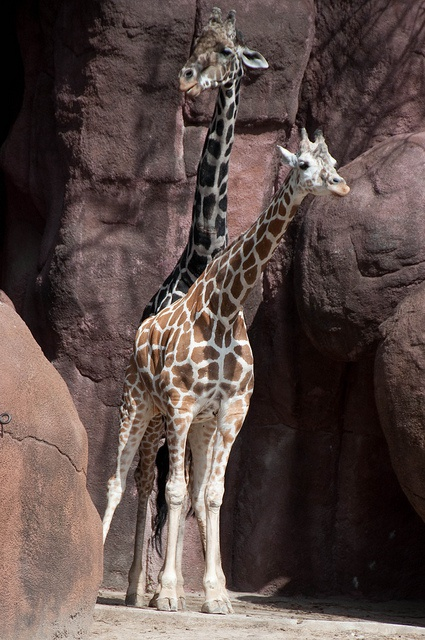Describe the objects in this image and their specific colors. I can see giraffe in black, gray, lightgray, and darkgray tones and giraffe in black, gray, and darkgray tones in this image. 